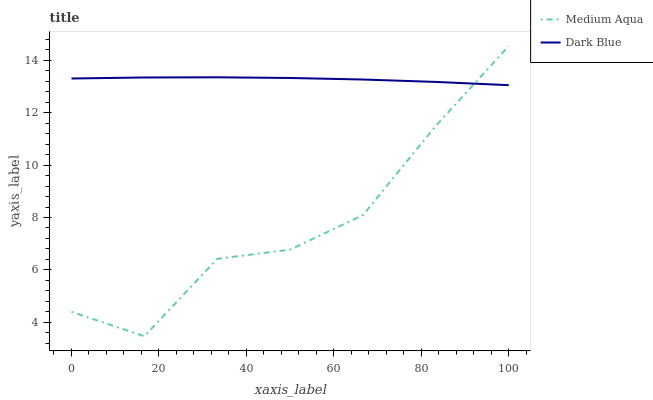Does Medium Aqua have the minimum area under the curve?
Answer yes or no. Yes. Does Dark Blue have the maximum area under the curve?
Answer yes or no. Yes. Does Medium Aqua have the maximum area under the curve?
Answer yes or no. No. Is Dark Blue the smoothest?
Answer yes or no. Yes. Is Medium Aqua the roughest?
Answer yes or no. Yes. Is Medium Aqua the smoothest?
Answer yes or no. No. Does Medium Aqua have the lowest value?
Answer yes or no. Yes. Does Medium Aqua have the highest value?
Answer yes or no. Yes. Does Dark Blue intersect Medium Aqua?
Answer yes or no. Yes. Is Dark Blue less than Medium Aqua?
Answer yes or no. No. Is Dark Blue greater than Medium Aqua?
Answer yes or no. No. 